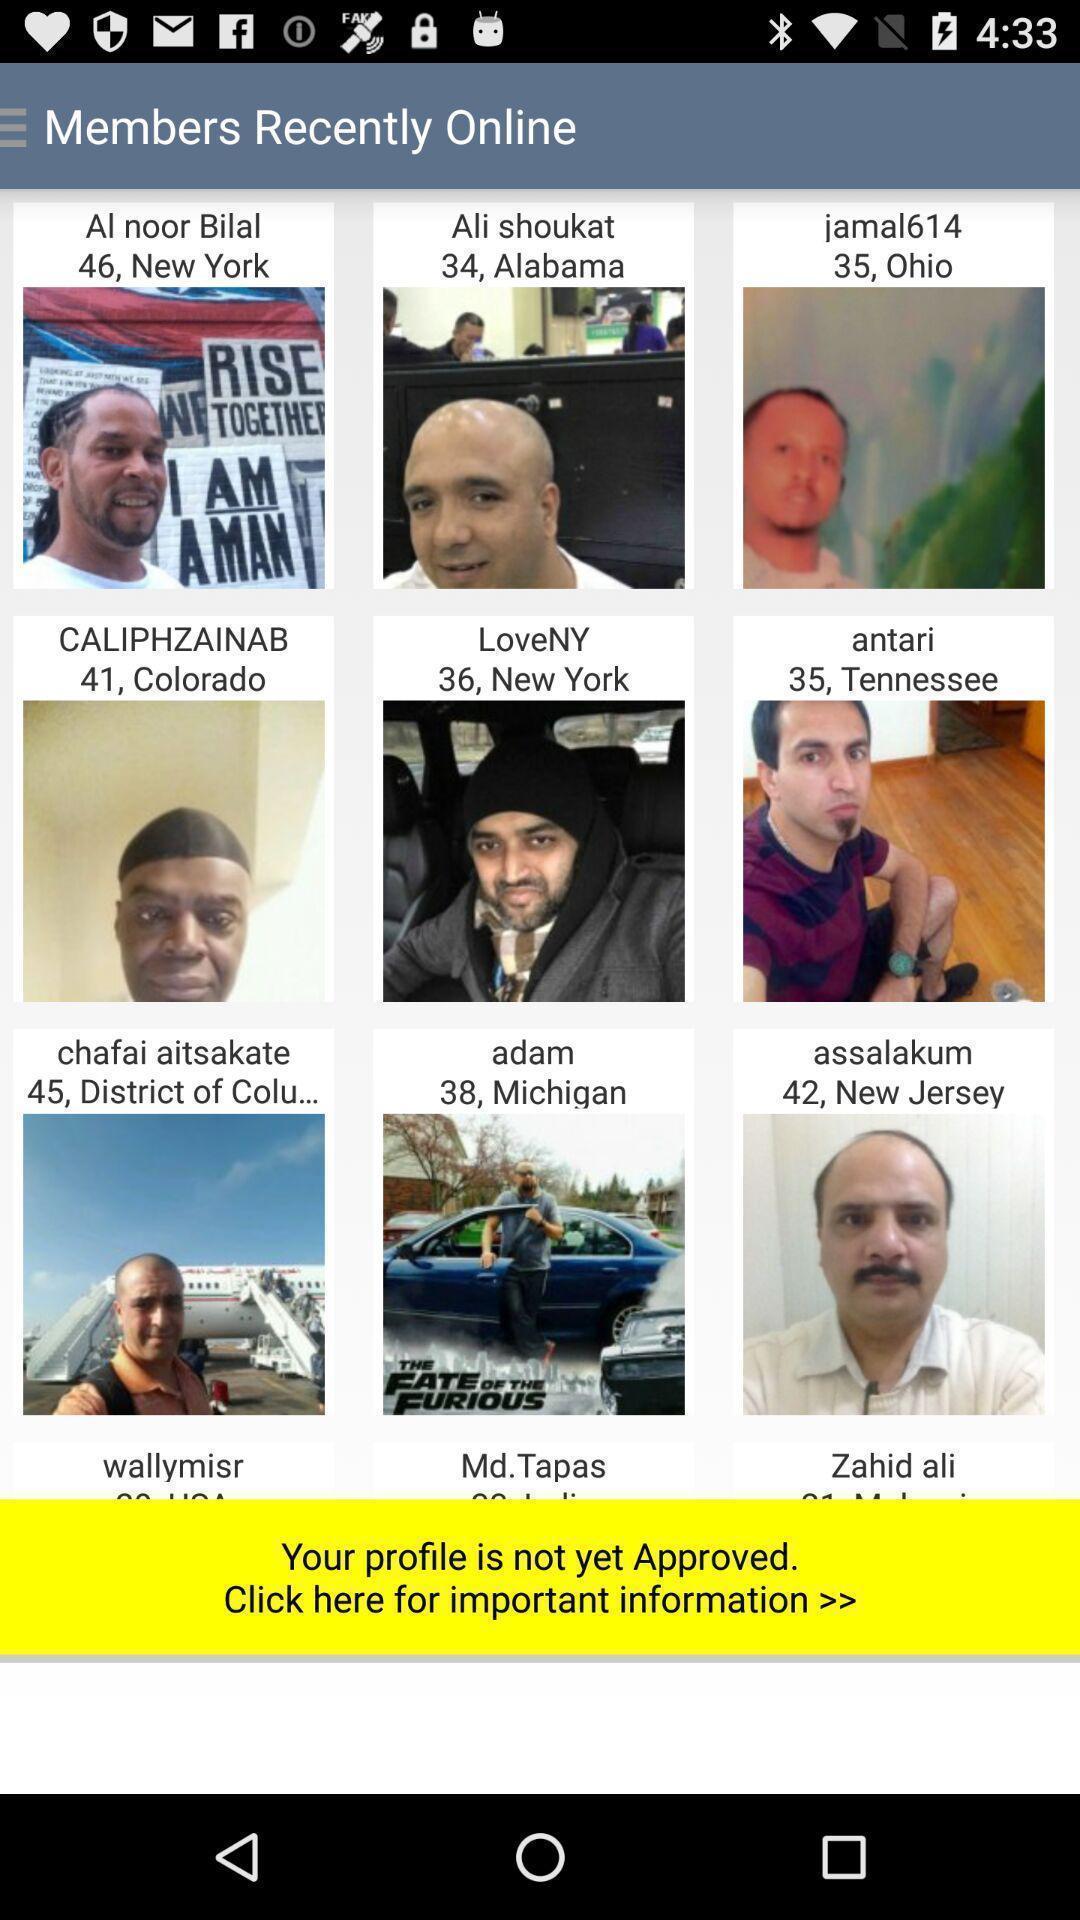Summarize the information in this screenshot. Screen showing list of various profiles recent online. 